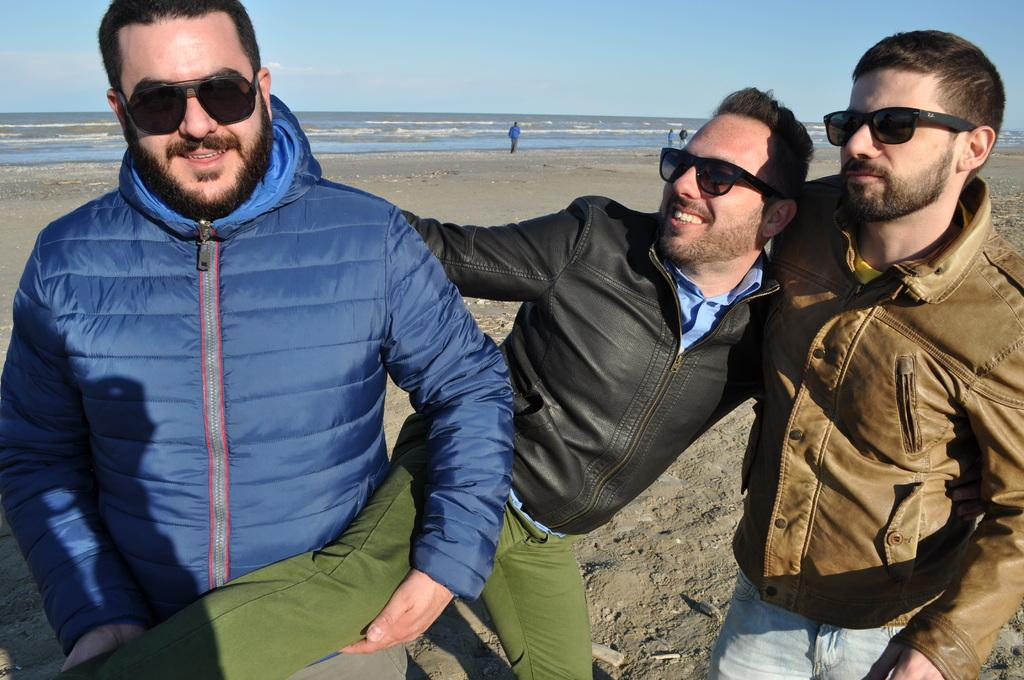How many people are posing for a photo in the image? There are three people standing and posing for a photo in the image. Can you describe the background of the image? There are people in the background of the image, and the ocean is visible in the background as well. What is visible at the top of the image? The sky is visible at the top of the image. What type of attempt can be seen in the image? There is no attempt visible in the image; it features three people posing for a photo. Can you describe the kitty playing with a ball of yarn in the image? There is no kitty or ball of yarn present in the image. 